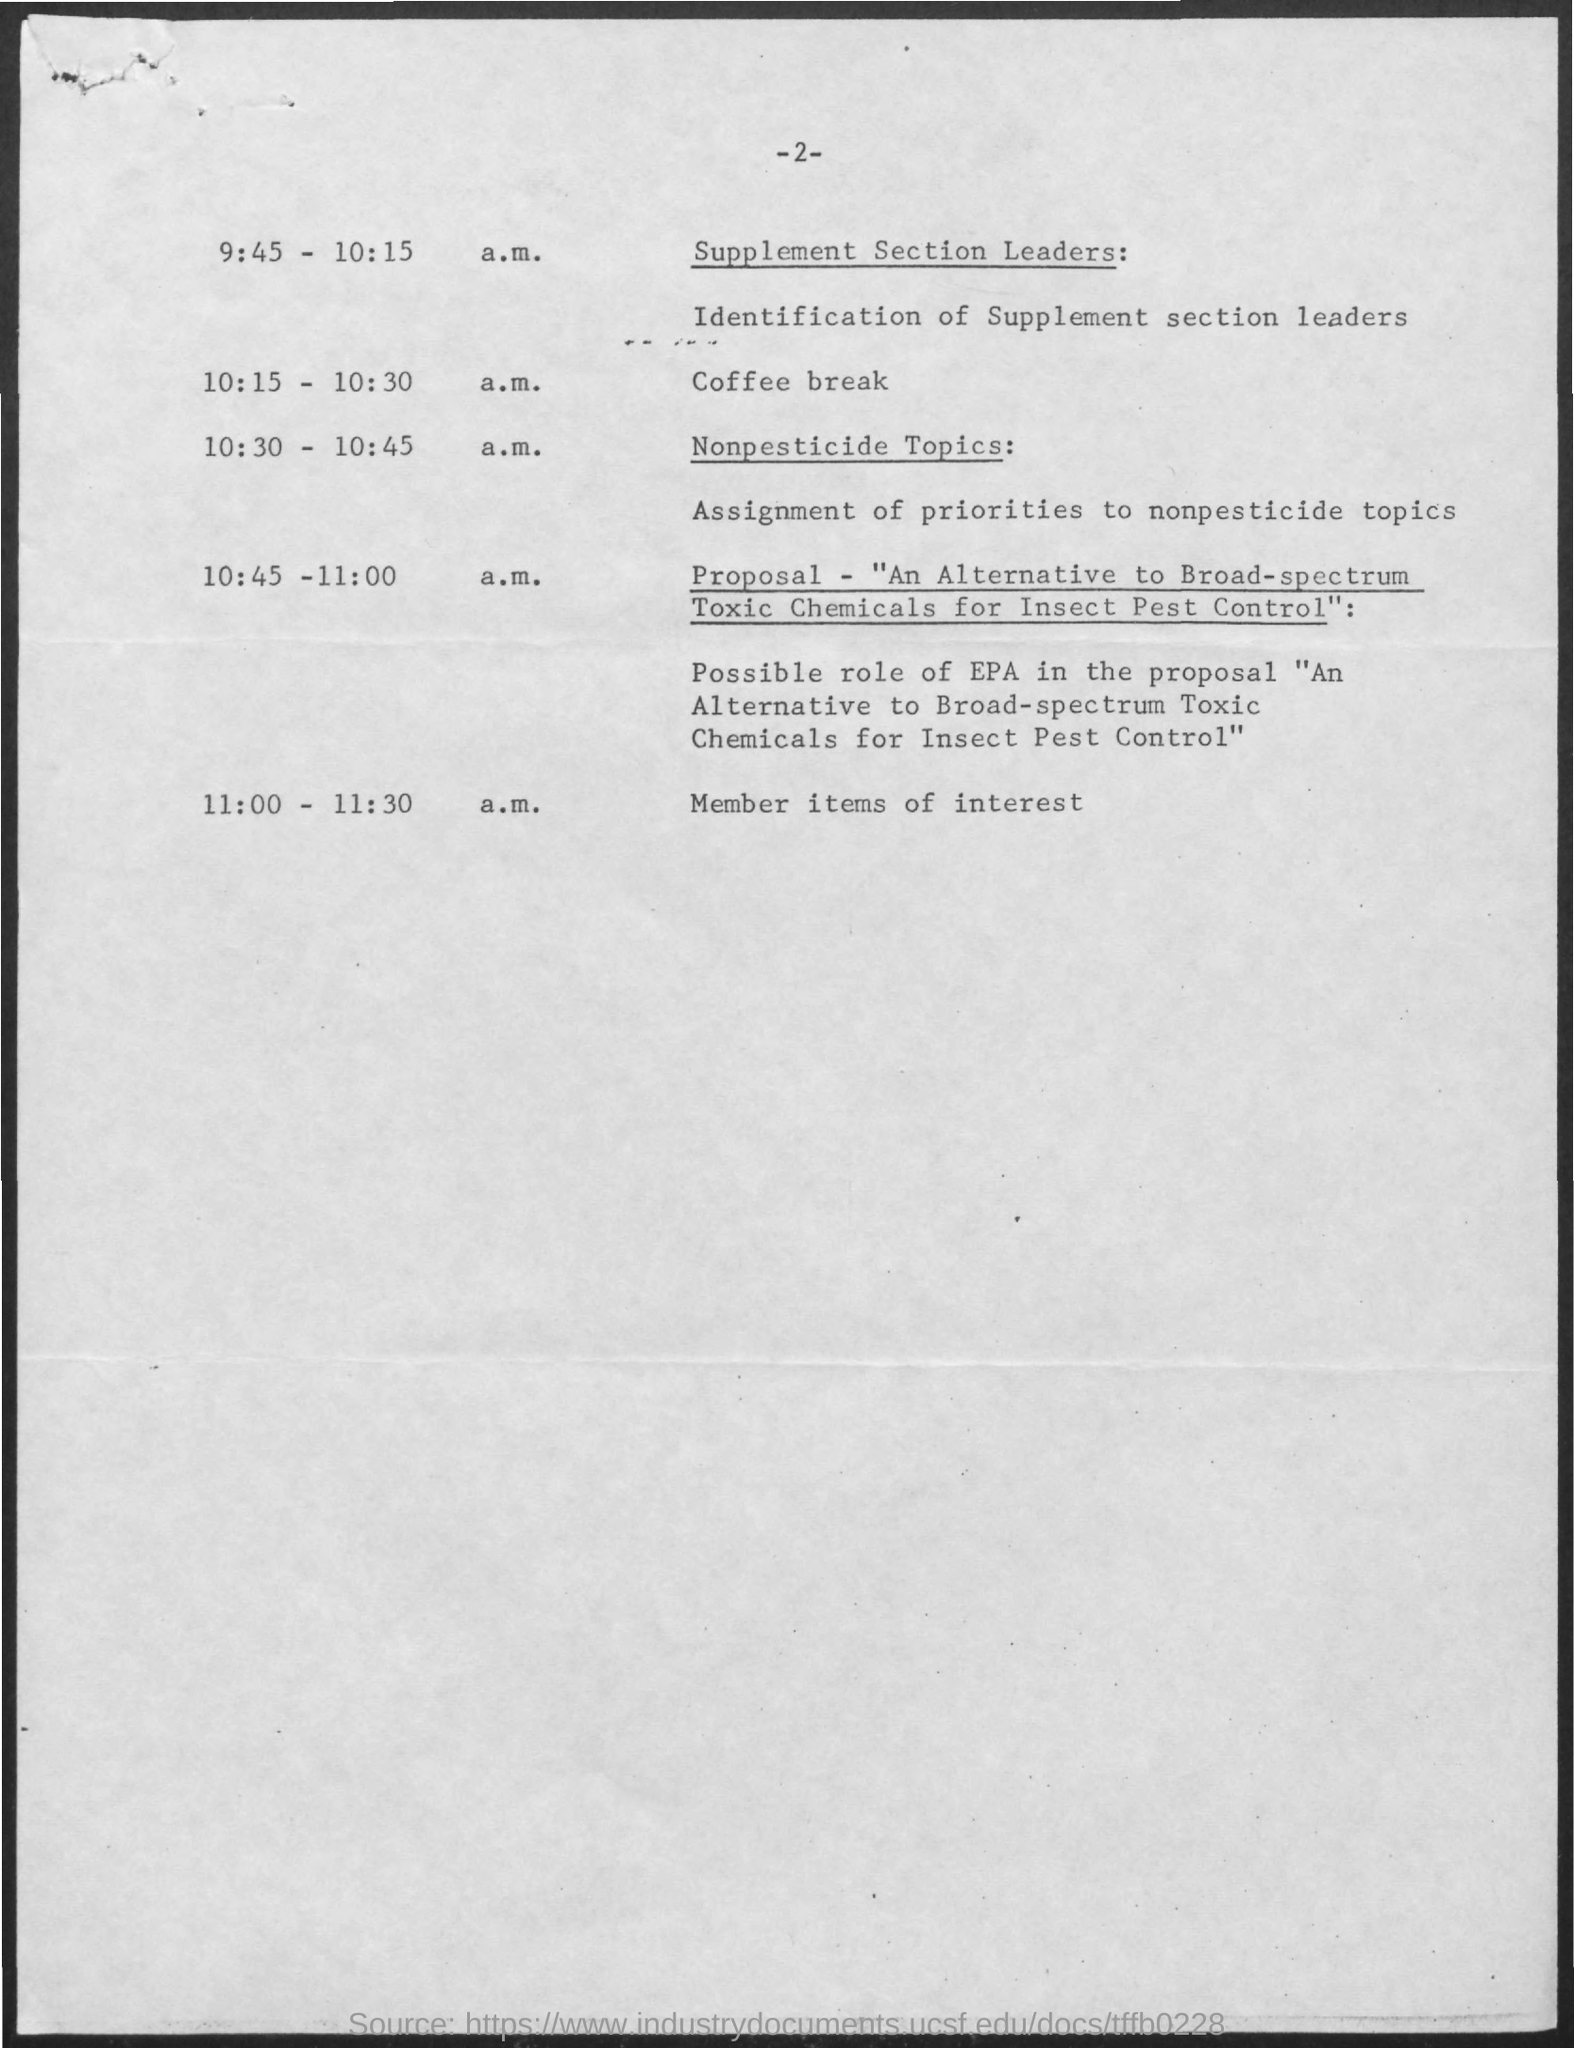Highlight a few significant elements in this photo. The assignment of priorities to nonpesticide topics refers to the process of determining the relative importance of different nonpesticide methods or approaches for controlling pests, based on factors such as their effectiveness, feasibility, and environmental impact. The coffee break shall occur between 10:15 and 10:30 a.m. The nonpesticide topics will take place from 10:30 to 10:45 a.m.. At 11:00-11:30 a.m., the program includes items of interest to members. Our proposal outlines an alternative to broad-spectrum toxic chemicals for insect pest control, which offers a more environmentally friendly and sustainable solution. 